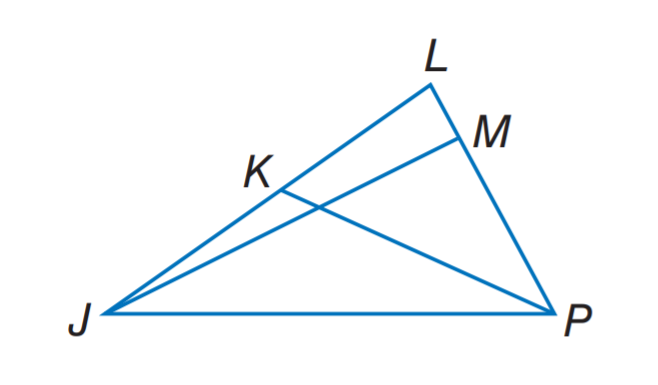Answer the mathemtical geometry problem and directly provide the correct option letter.
Question: In \triangle J L P, m \angle J M P = 3 x - 6, J K = 3 y - 2, and L K = 5 y - 8. Find L K if P K is a median.
Choices: A: 2 B: 5 C: 7 D: 8 C 